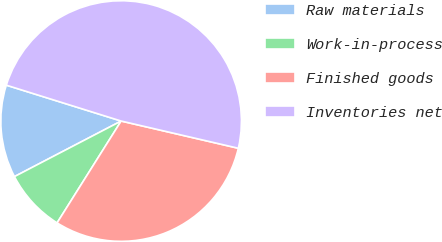Convert chart to OTSL. <chart><loc_0><loc_0><loc_500><loc_500><pie_chart><fcel>Raw materials<fcel>Work-in-process<fcel>Finished goods<fcel>Inventories net<nl><fcel>12.46%<fcel>8.42%<fcel>30.3%<fcel>48.81%<nl></chart> 